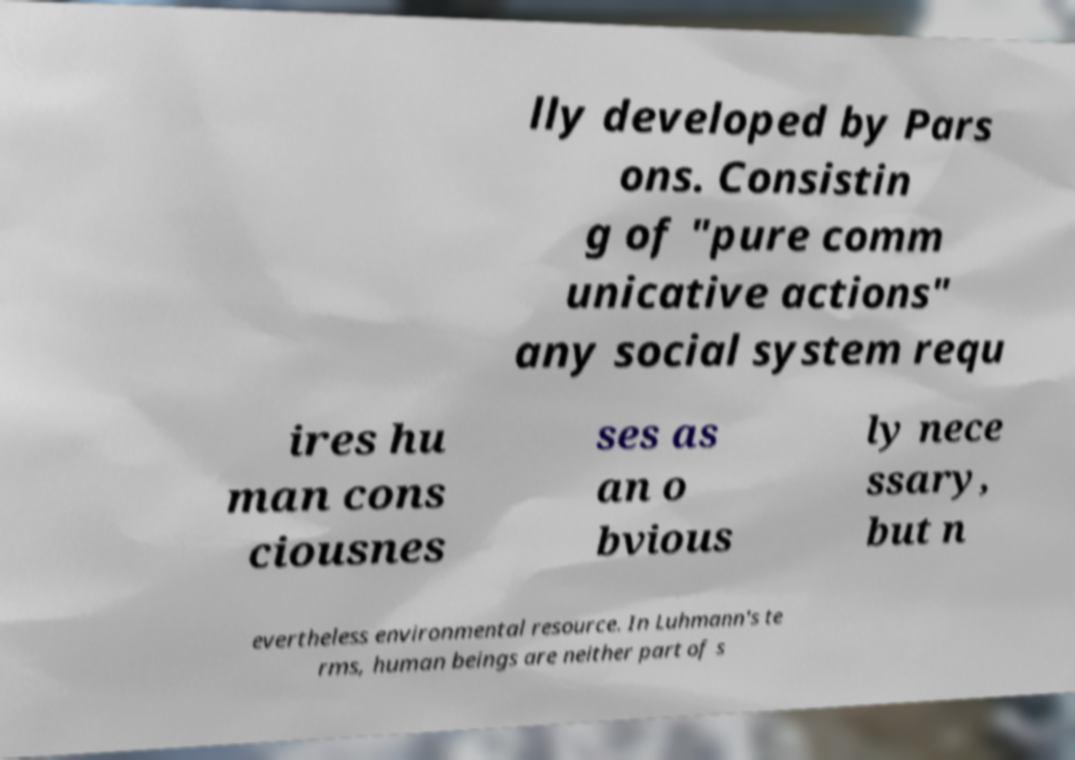For documentation purposes, I need the text within this image transcribed. Could you provide that? lly developed by Pars ons. Consistin g of "pure comm unicative actions" any social system requ ires hu man cons ciousnes ses as an o bvious ly nece ssary, but n evertheless environmental resource. In Luhmann's te rms, human beings are neither part of s 